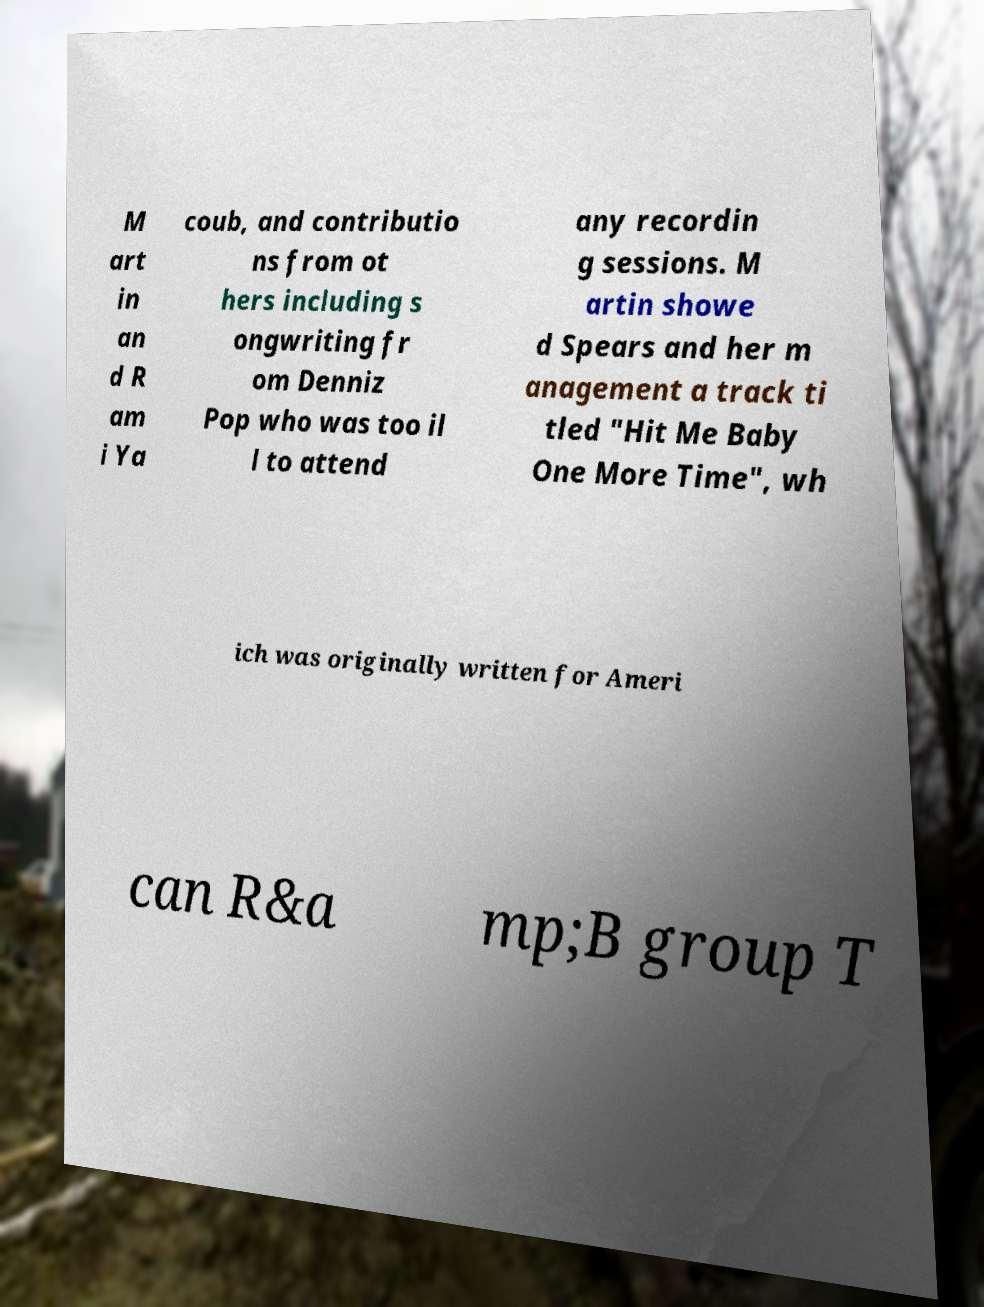I need the written content from this picture converted into text. Can you do that? M art in an d R am i Ya coub, and contributio ns from ot hers including s ongwriting fr om Denniz Pop who was too il l to attend any recordin g sessions. M artin showe d Spears and her m anagement a track ti tled "Hit Me Baby One More Time", wh ich was originally written for Ameri can R&a mp;B group T 